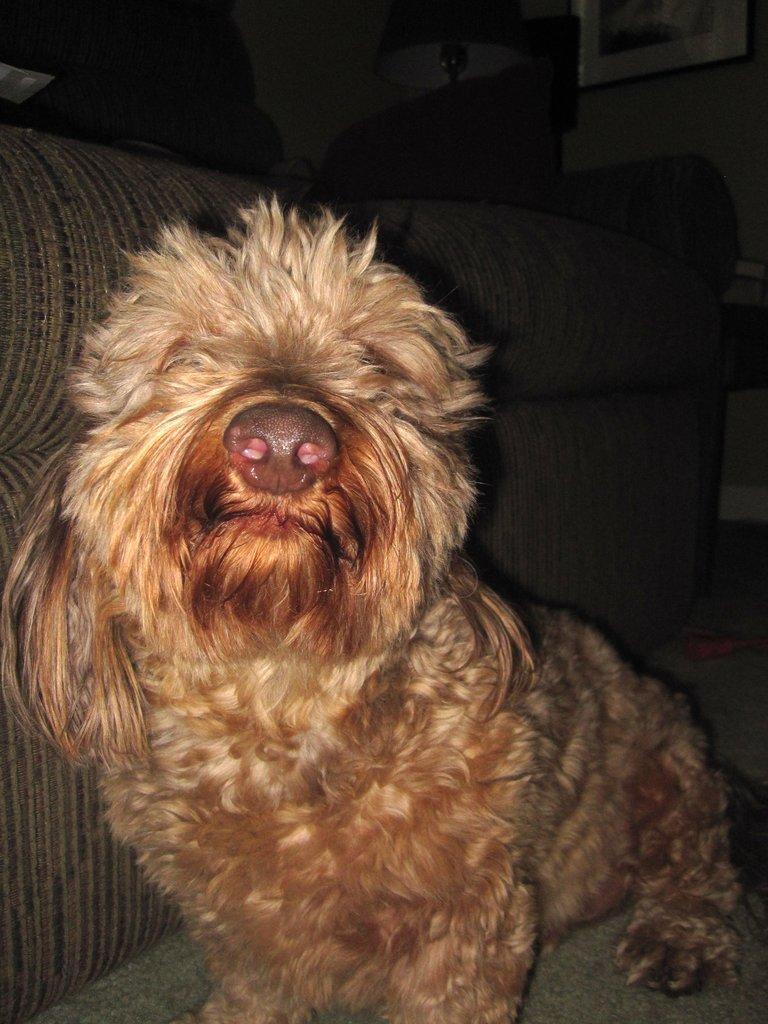Describe this image in one or two sentences. In this picture we can see a dog sitting, on the left side there is a sofa, we can see a lamp and a photo frame in the background. 